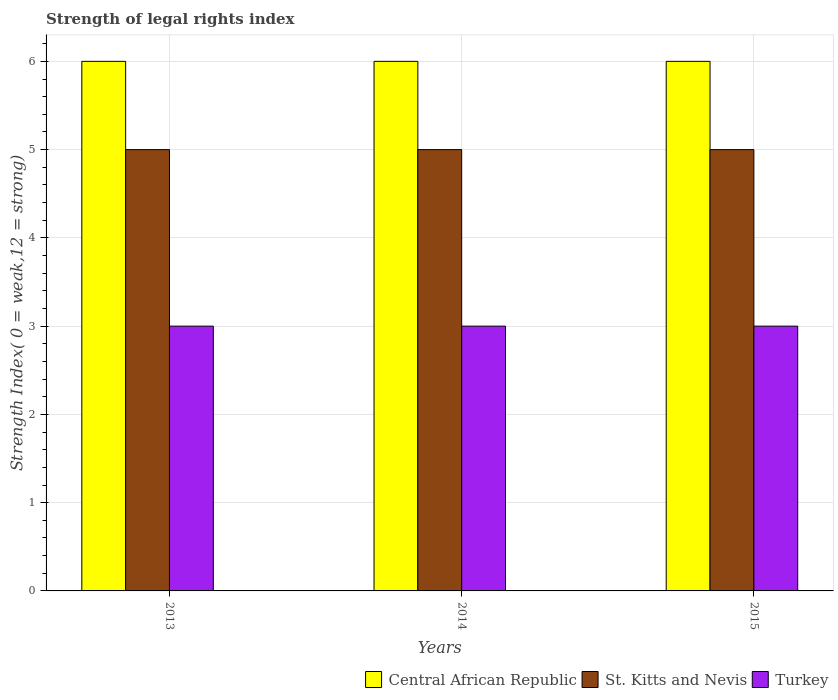How many different coloured bars are there?
Make the answer very short. 3. Are the number of bars per tick equal to the number of legend labels?
Give a very brief answer. Yes. Are the number of bars on each tick of the X-axis equal?
Offer a very short reply. Yes. How many bars are there on the 3rd tick from the right?
Keep it short and to the point. 3. In how many cases, is the number of bars for a given year not equal to the number of legend labels?
Offer a terse response. 0. What is the strength index in St. Kitts and Nevis in 2013?
Ensure brevity in your answer.  5. Across all years, what is the maximum strength index in Central African Republic?
Your answer should be compact. 6. Across all years, what is the minimum strength index in Central African Republic?
Offer a terse response. 6. In which year was the strength index in St. Kitts and Nevis minimum?
Offer a terse response. 2013. What is the total strength index in St. Kitts and Nevis in the graph?
Your answer should be compact. 15. What is the difference between the strength index in St. Kitts and Nevis in 2014 and that in 2015?
Offer a very short reply. 0. What is the difference between the strength index in St. Kitts and Nevis in 2015 and the strength index in Turkey in 2013?
Provide a short and direct response. 2. In the year 2013, what is the difference between the strength index in Central African Republic and strength index in St. Kitts and Nevis?
Offer a very short reply. 1. Is the strength index in Central African Republic in 2014 less than that in 2015?
Your answer should be compact. No. Is the difference between the strength index in Central African Republic in 2013 and 2015 greater than the difference between the strength index in St. Kitts and Nevis in 2013 and 2015?
Ensure brevity in your answer.  No. What is the difference between the highest and the second highest strength index in Central African Republic?
Make the answer very short. 0. What is the difference between the highest and the lowest strength index in Turkey?
Give a very brief answer. 0. In how many years, is the strength index in Central African Republic greater than the average strength index in Central African Republic taken over all years?
Offer a very short reply. 0. What does the 2nd bar from the left in 2014 represents?
Offer a very short reply. St. Kitts and Nevis. What does the 2nd bar from the right in 2014 represents?
Keep it short and to the point. St. Kitts and Nevis. How many bars are there?
Your answer should be very brief. 9. Are all the bars in the graph horizontal?
Ensure brevity in your answer.  No. How many years are there in the graph?
Keep it short and to the point. 3. Does the graph contain any zero values?
Your answer should be compact. No. Does the graph contain grids?
Make the answer very short. Yes. What is the title of the graph?
Provide a short and direct response. Strength of legal rights index. What is the label or title of the Y-axis?
Provide a succinct answer. Strength Index( 0 = weak,12 = strong). What is the Strength Index( 0 = weak,12 = strong) of St. Kitts and Nevis in 2013?
Make the answer very short. 5. What is the Strength Index( 0 = weak,12 = strong) of Central African Republic in 2014?
Keep it short and to the point. 6. What is the Strength Index( 0 = weak,12 = strong) in St. Kitts and Nevis in 2014?
Give a very brief answer. 5. What is the Strength Index( 0 = weak,12 = strong) in Central African Republic in 2015?
Make the answer very short. 6. What is the Strength Index( 0 = weak,12 = strong) of St. Kitts and Nevis in 2015?
Provide a short and direct response. 5. What is the Strength Index( 0 = weak,12 = strong) in Turkey in 2015?
Keep it short and to the point. 3. Across all years, what is the maximum Strength Index( 0 = weak,12 = strong) of St. Kitts and Nevis?
Offer a very short reply. 5. Across all years, what is the minimum Strength Index( 0 = weak,12 = strong) in Central African Republic?
Make the answer very short. 6. What is the total Strength Index( 0 = weak,12 = strong) in Central African Republic in the graph?
Offer a terse response. 18. What is the total Strength Index( 0 = weak,12 = strong) of St. Kitts and Nevis in the graph?
Provide a succinct answer. 15. What is the difference between the Strength Index( 0 = weak,12 = strong) of Central African Republic in 2013 and that in 2014?
Offer a very short reply. 0. What is the difference between the Strength Index( 0 = weak,12 = strong) of Turkey in 2013 and that in 2014?
Give a very brief answer. 0. What is the difference between the Strength Index( 0 = weak,12 = strong) of Central African Republic in 2013 and that in 2015?
Offer a terse response. 0. What is the difference between the Strength Index( 0 = weak,12 = strong) in Turkey in 2013 and that in 2015?
Provide a short and direct response. 0. What is the difference between the Strength Index( 0 = weak,12 = strong) of Central African Republic in 2014 and that in 2015?
Provide a short and direct response. 0. What is the difference between the Strength Index( 0 = weak,12 = strong) in Central African Republic in 2013 and the Strength Index( 0 = weak,12 = strong) in St. Kitts and Nevis in 2014?
Provide a short and direct response. 1. What is the difference between the Strength Index( 0 = weak,12 = strong) in Central African Republic in 2013 and the Strength Index( 0 = weak,12 = strong) in St. Kitts and Nevis in 2015?
Provide a succinct answer. 1. What is the difference between the Strength Index( 0 = weak,12 = strong) of St. Kitts and Nevis in 2014 and the Strength Index( 0 = weak,12 = strong) of Turkey in 2015?
Offer a terse response. 2. What is the average Strength Index( 0 = weak,12 = strong) of St. Kitts and Nevis per year?
Make the answer very short. 5. What is the average Strength Index( 0 = weak,12 = strong) in Turkey per year?
Offer a terse response. 3. In the year 2013, what is the difference between the Strength Index( 0 = weak,12 = strong) of St. Kitts and Nevis and Strength Index( 0 = weak,12 = strong) of Turkey?
Offer a very short reply. 2. In the year 2014, what is the difference between the Strength Index( 0 = weak,12 = strong) of Central African Republic and Strength Index( 0 = weak,12 = strong) of Turkey?
Make the answer very short. 3. In the year 2014, what is the difference between the Strength Index( 0 = weak,12 = strong) of St. Kitts and Nevis and Strength Index( 0 = weak,12 = strong) of Turkey?
Your response must be concise. 2. In the year 2015, what is the difference between the Strength Index( 0 = weak,12 = strong) of Central African Republic and Strength Index( 0 = weak,12 = strong) of St. Kitts and Nevis?
Provide a short and direct response. 1. What is the ratio of the Strength Index( 0 = weak,12 = strong) in Central African Republic in 2013 to that in 2014?
Keep it short and to the point. 1. What is the ratio of the Strength Index( 0 = weak,12 = strong) in St. Kitts and Nevis in 2013 to that in 2014?
Provide a short and direct response. 1. What is the ratio of the Strength Index( 0 = weak,12 = strong) of Turkey in 2013 to that in 2014?
Make the answer very short. 1. What is the ratio of the Strength Index( 0 = weak,12 = strong) in Central African Republic in 2013 to that in 2015?
Your answer should be very brief. 1. What is the difference between the highest and the second highest Strength Index( 0 = weak,12 = strong) in Central African Republic?
Your answer should be very brief. 0. What is the difference between the highest and the lowest Strength Index( 0 = weak,12 = strong) of Central African Republic?
Make the answer very short. 0. What is the difference between the highest and the lowest Strength Index( 0 = weak,12 = strong) of Turkey?
Give a very brief answer. 0. 